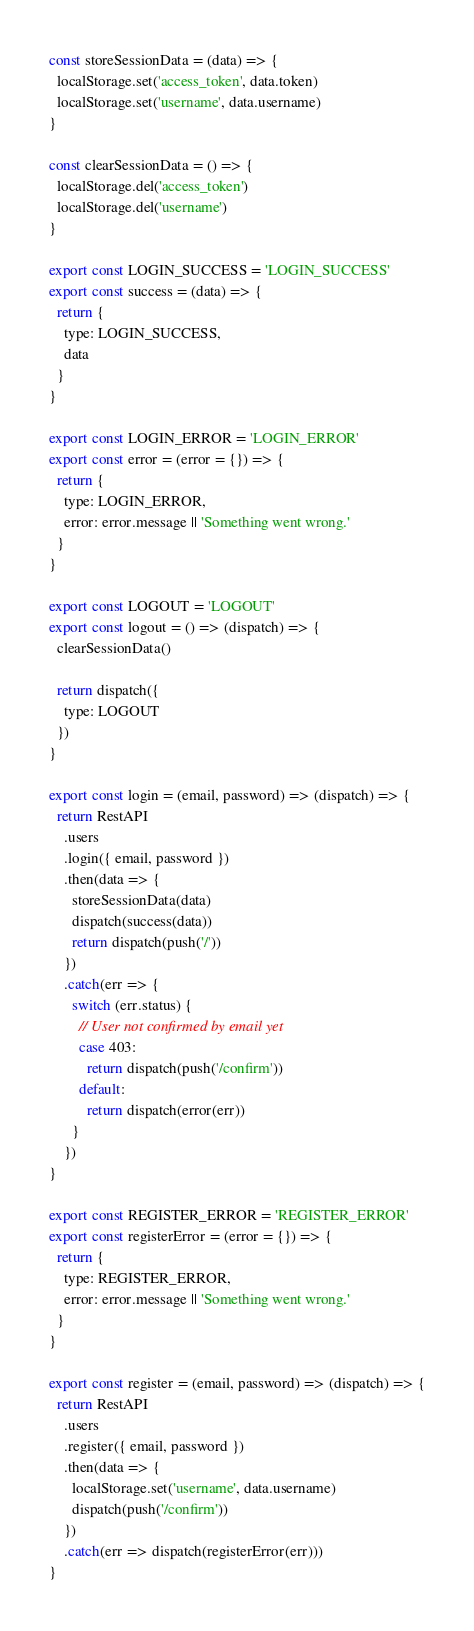<code> <loc_0><loc_0><loc_500><loc_500><_JavaScript_>const storeSessionData = (data) => {
  localStorage.set('access_token', data.token)
  localStorage.set('username', data.username)
}

const clearSessionData = () => {
  localStorage.del('access_token')
  localStorage.del('username')
}

export const LOGIN_SUCCESS = 'LOGIN_SUCCESS'
export const success = (data) => {
  return {
    type: LOGIN_SUCCESS,
    data
  }
}

export const LOGIN_ERROR = 'LOGIN_ERROR'
export const error = (error = {}) => {
  return {
    type: LOGIN_ERROR,
    error: error.message || 'Something went wrong.'
  }
}

export const LOGOUT = 'LOGOUT'
export const logout = () => (dispatch) => {
  clearSessionData()

  return dispatch({
    type: LOGOUT
  })
}

export const login = (email, password) => (dispatch) => {
  return RestAPI
    .users
    .login({ email, password })
    .then(data => {
      storeSessionData(data)
      dispatch(success(data))
      return dispatch(push('/'))
    })
    .catch(err => {
      switch (err.status) {
        // User not confirmed by email yet
        case 403:
          return dispatch(push('/confirm'))
        default:
          return dispatch(error(err)) 
      }
    })
}

export const REGISTER_ERROR = 'REGISTER_ERROR'
export const registerError = (error = {}) => {
  return {
    type: REGISTER_ERROR,
    error: error.message || 'Something went wrong.'
  }
}

export const register = (email, password) => (dispatch) => {
  return RestAPI
    .users
    .register({ email, password })
    .then(data => {
      localStorage.set('username', data.username)
      dispatch(push('/confirm'))
    })
    .catch(err => dispatch(registerError(err)))
}
</code> 